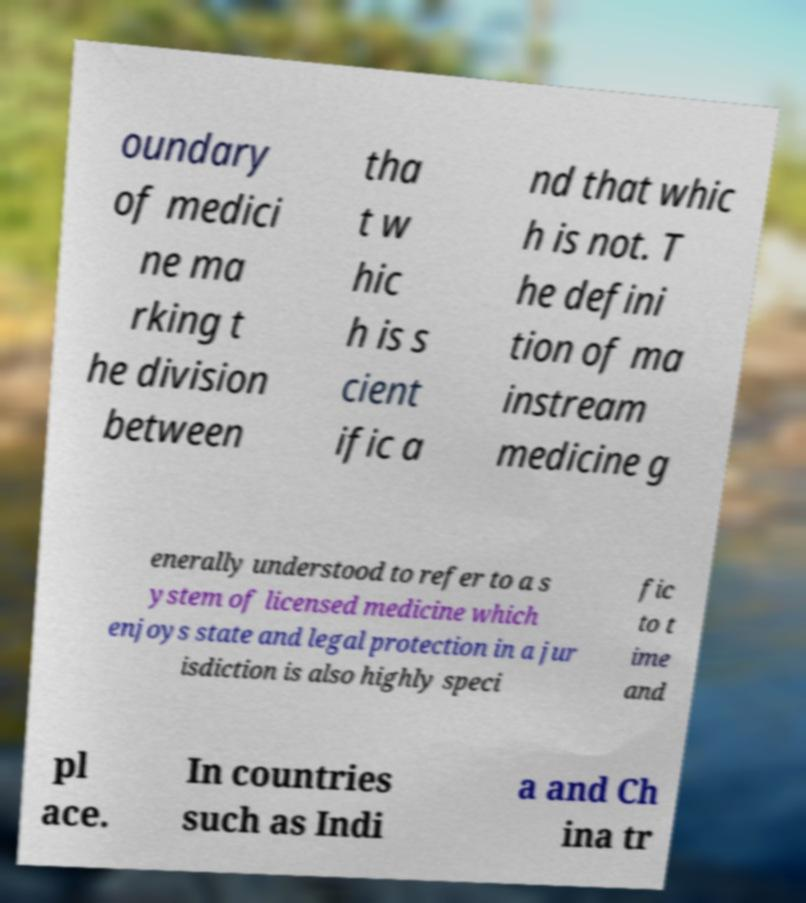Can you read and provide the text displayed in the image?This photo seems to have some interesting text. Can you extract and type it out for me? oundary of medici ne ma rking t he division between tha t w hic h is s cient ific a nd that whic h is not. T he defini tion of ma instream medicine g enerally understood to refer to a s ystem of licensed medicine which enjoys state and legal protection in a jur isdiction is also highly speci fic to t ime and pl ace. In countries such as Indi a and Ch ina tr 